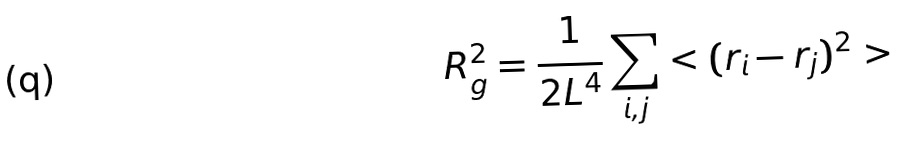Convert formula to latex. <formula><loc_0><loc_0><loc_500><loc_500>R _ { g } ^ { 2 } = \frac { 1 } { 2 L ^ { 4 } } \sum _ { i , j } < ( { r } _ { i } - { r } _ { j } ) ^ { 2 } ></formula> 